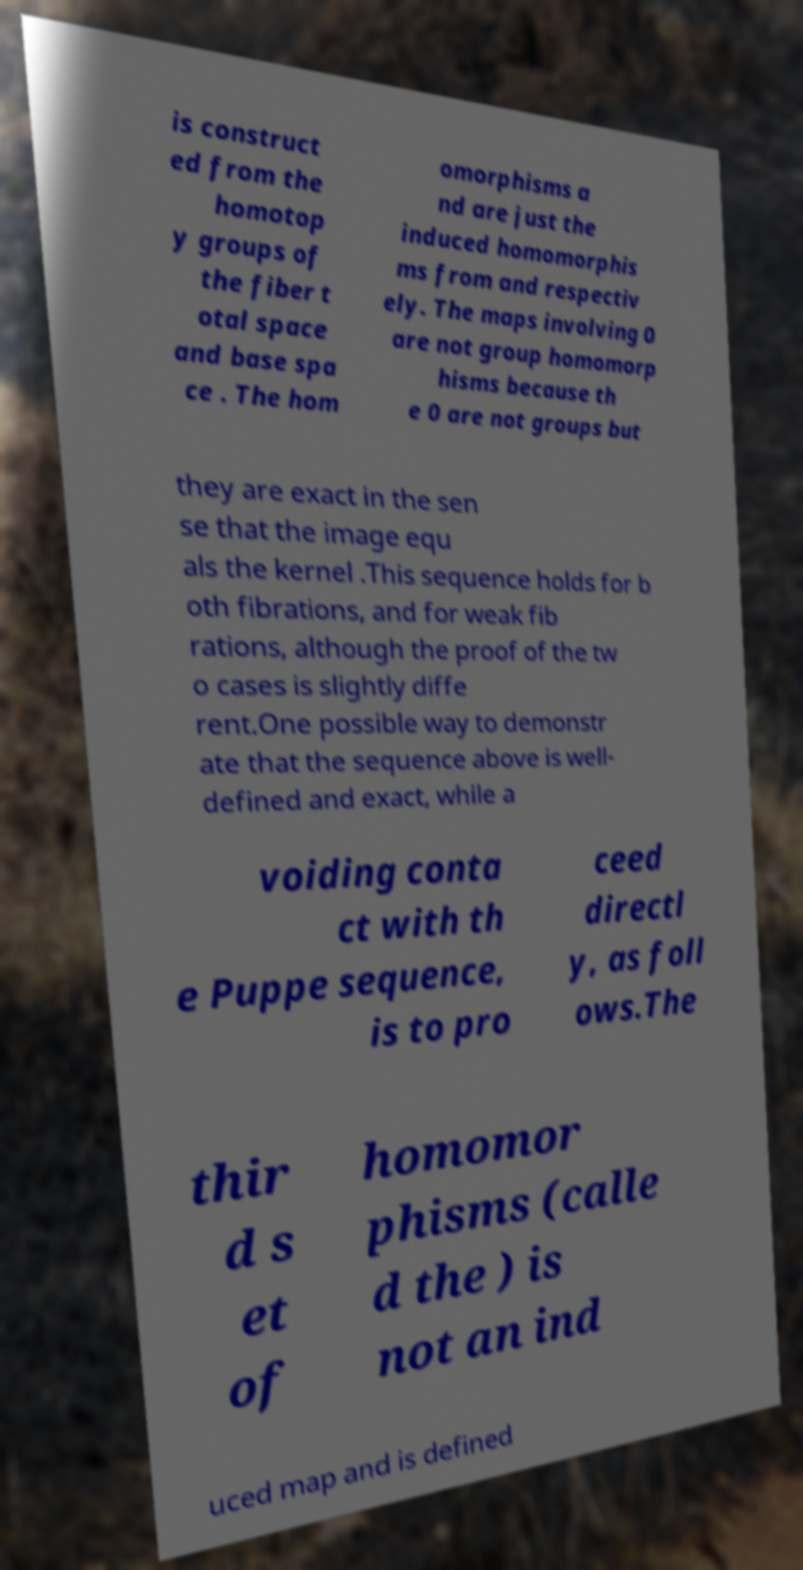Could you extract and type out the text from this image? is construct ed from the homotop y groups of the fiber t otal space and base spa ce . The hom omorphisms a nd are just the induced homomorphis ms from and respectiv ely. The maps involving 0 are not group homomorp hisms because th e 0 are not groups but they are exact in the sen se that the image equ als the kernel .This sequence holds for b oth fibrations, and for weak fib rations, although the proof of the tw o cases is slightly diffe rent.One possible way to demonstr ate that the sequence above is well- defined and exact, while a voiding conta ct with th e Puppe sequence, is to pro ceed directl y, as foll ows.The thir d s et of homomor phisms (calle d the ) is not an ind uced map and is defined 